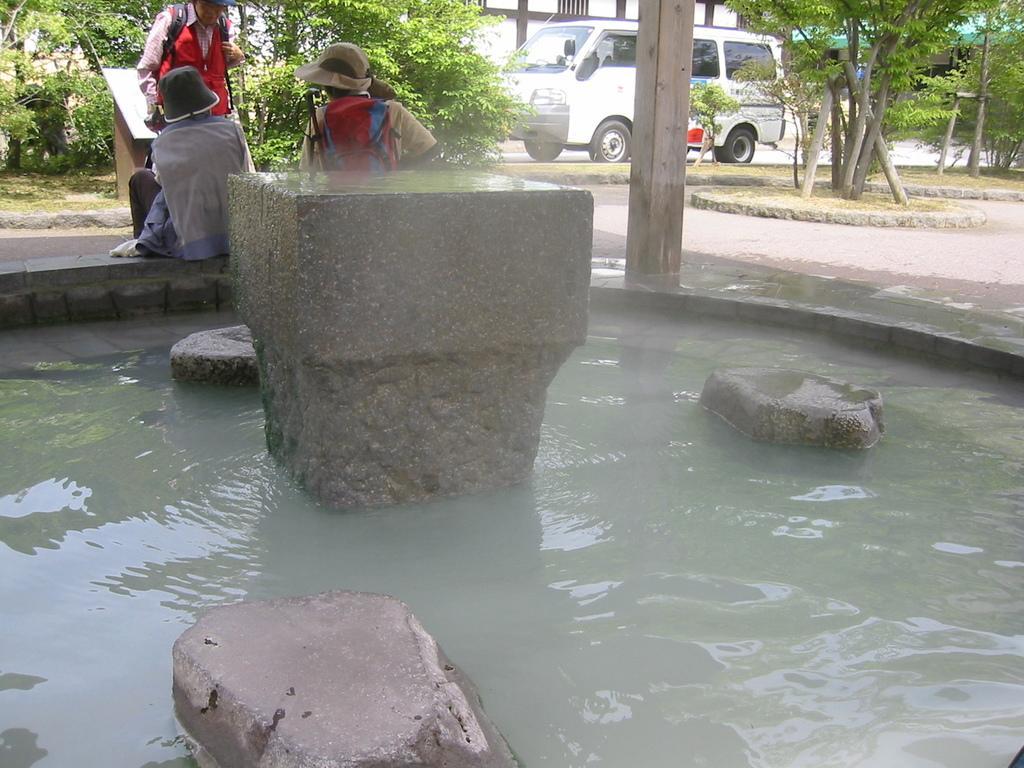Can you describe this image briefly? In this image at front there is a pond and inside the pond there are stones. Three people are sitting in front of the pond. We can see a van on the road. At the background there are trees and buildings. 